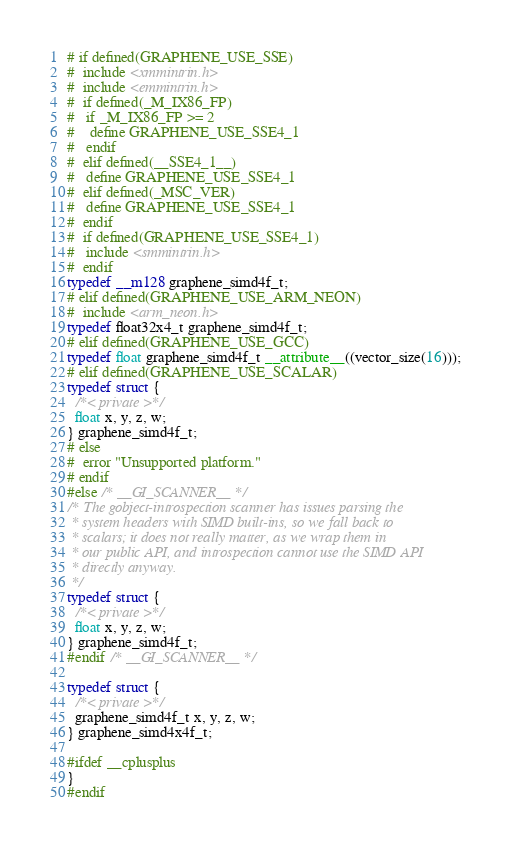Convert code to text. <code><loc_0><loc_0><loc_500><loc_500><_C_># if defined(GRAPHENE_USE_SSE)
#  include <xmmintrin.h>
#  include <emmintrin.h>
#  if defined(_M_IX86_FP)
#   if _M_IX86_FP >= 2
#    define GRAPHENE_USE_SSE4_1
#   endif
#  elif defined(__SSE4_1__)
#   define GRAPHENE_USE_SSE4_1
#  elif defined(_MSC_VER)
#   define GRAPHENE_USE_SSE4_1
#  endif
#  if defined(GRAPHENE_USE_SSE4_1)
#   include <smmintrin.h>
#  endif
typedef __m128 graphene_simd4f_t;
# elif defined(GRAPHENE_USE_ARM_NEON)
#  include <arm_neon.h>
typedef float32x4_t graphene_simd4f_t;
# elif defined(GRAPHENE_USE_GCC)
typedef float graphene_simd4f_t __attribute__((vector_size(16)));
# elif defined(GRAPHENE_USE_SCALAR)
typedef struct {
  /*< private >*/
  float x, y, z, w;
} graphene_simd4f_t;
# else
#  error "Unsupported platform."
# endif
#else /* __GI_SCANNER__ */
/* The gobject-introspection scanner has issues parsing the
 * system headers with SIMD built-ins, so we fall back to
 * scalars; it does not really matter, as we wrap them in
 * our public API, and introspection cannot use the SIMD API
 * directly anyway.
 */
typedef struct {
  /*< private >*/
  float x, y, z, w;
} graphene_simd4f_t;
#endif /* __GI_SCANNER__ */

typedef struct {
  /*< private >*/
  graphene_simd4f_t x, y, z, w;
} graphene_simd4x4f_t;

#ifdef __cplusplus
}
#endif
</code> 